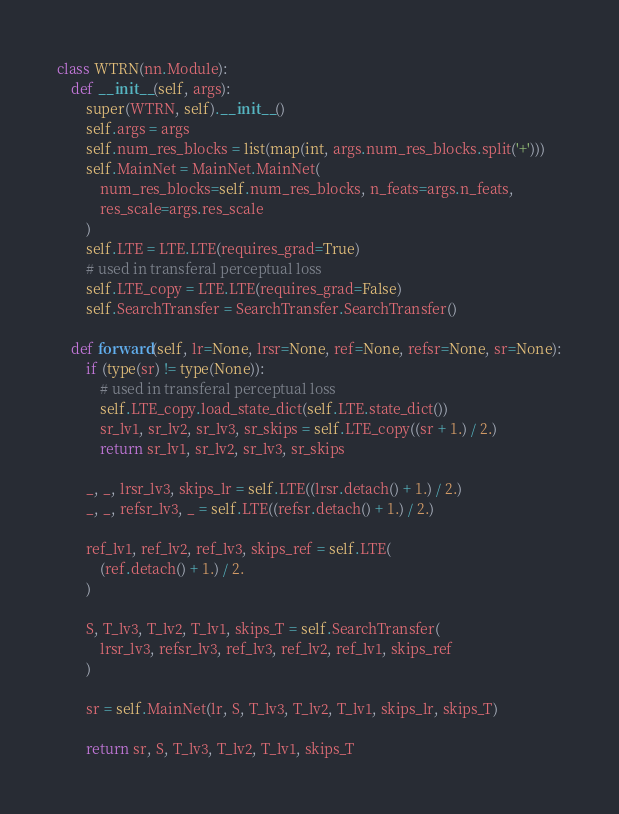Convert code to text. <code><loc_0><loc_0><loc_500><loc_500><_Python_>

class WTRN(nn.Module):
    def __init__(self, args):
        super(WTRN, self).__init__()
        self.args = args
        self.num_res_blocks = list(map(int, args.num_res_blocks.split('+')))
        self.MainNet = MainNet.MainNet(
            num_res_blocks=self.num_res_blocks, n_feats=args.n_feats,
            res_scale=args.res_scale
        )
        self.LTE = LTE.LTE(requires_grad=True)
        # used in transferal perceptual loss
        self.LTE_copy = LTE.LTE(requires_grad=False)
        self.SearchTransfer = SearchTransfer.SearchTransfer()

    def forward(self, lr=None, lrsr=None, ref=None, refsr=None, sr=None):
        if (type(sr) != type(None)):
            # used in transferal perceptual loss
            self.LTE_copy.load_state_dict(self.LTE.state_dict())
            sr_lv1, sr_lv2, sr_lv3, sr_skips = self.LTE_copy((sr + 1.) / 2.)
            return sr_lv1, sr_lv2, sr_lv3, sr_skips

        _, _, lrsr_lv3, skips_lr = self.LTE((lrsr.detach() + 1.) / 2.)
        _, _, refsr_lv3, _ = self.LTE((refsr.detach() + 1.) / 2.)

        ref_lv1, ref_lv2, ref_lv3, skips_ref = self.LTE(
            (ref.detach() + 1.) / 2.
        )

        S, T_lv3, T_lv2, T_lv1, skips_T = self.SearchTransfer(
            lrsr_lv3, refsr_lv3, ref_lv3, ref_lv2, ref_lv1, skips_ref
        )

        sr = self.MainNet(lr, S, T_lv3, T_lv2, T_lv1, skips_lr, skips_T)

        return sr, S, T_lv3, T_lv2, T_lv1, skips_T
</code> 